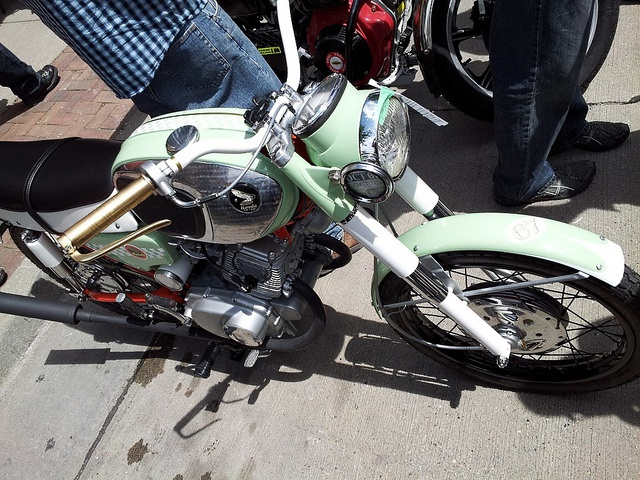Describe the objects in this image and their specific colors. I can see motorcycle in black, ivory, gray, and darkgray tones, people in black, gray, and darkblue tones, people in black, navy, gray, and blue tones, and people in black, gray, and darkgray tones in this image. 